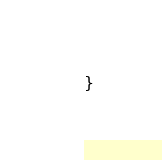<code> <loc_0><loc_0><loc_500><loc_500><_Awk_>}
</code> 